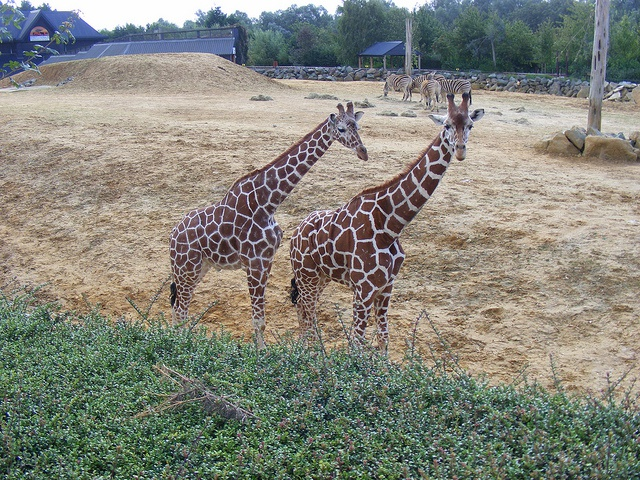Describe the objects in this image and their specific colors. I can see giraffe in lavender, maroon, darkgray, gray, and black tones, giraffe in lavender, gray, maroon, darkgray, and purple tones, zebra in lavender, darkgray, and gray tones, zebra in lavender, gray, darkgray, and black tones, and zebra in lavender, darkgray, and gray tones in this image. 